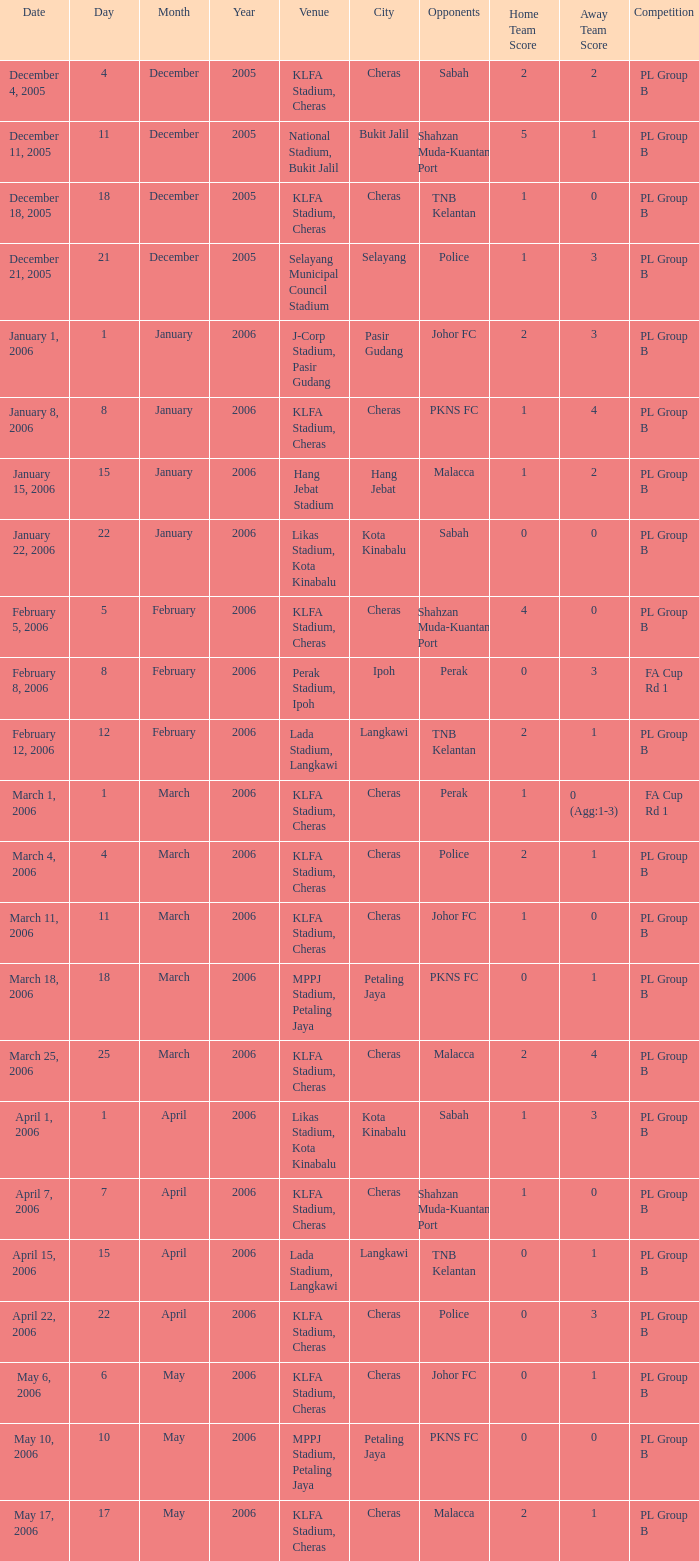Which Competition has Opponents of pkns fc, and a Score of 0-0? PL Group B. 